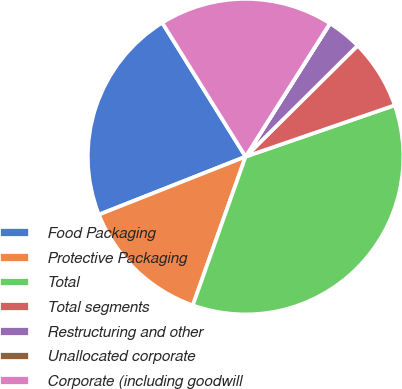Convert chart. <chart><loc_0><loc_0><loc_500><loc_500><pie_chart><fcel>Food Packaging<fcel>Protective Packaging<fcel>Total<fcel>Total segments<fcel>Restructuring and other<fcel>Unallocated corporate<fcel>Corporate (including goodwill<nl><fcel>22.13%<fcel>13.58%<fcel>35.71%<fcel>7.15%<fcel>3.58%<fcel>0.01%<fcel>17.84%<nl></chart> 